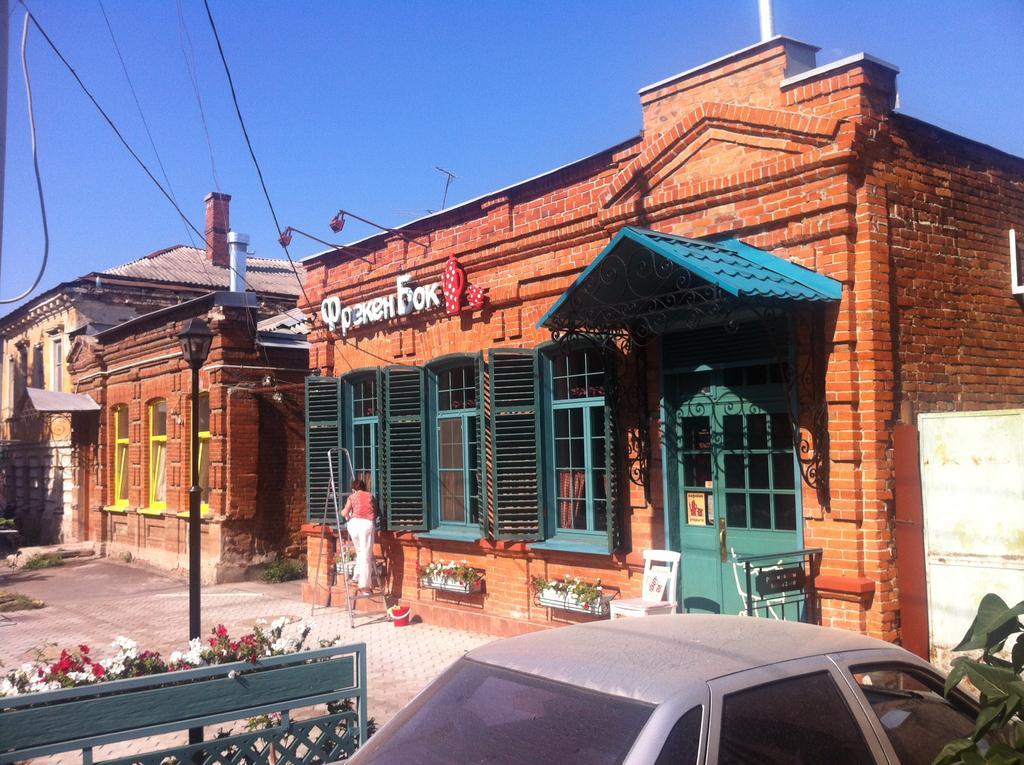Describe this image in one or two sentences. There is a car, it seems like a boundary and flowers in the foreground area of the image, there are houses, plants, a person, wires and the sky in the background. 